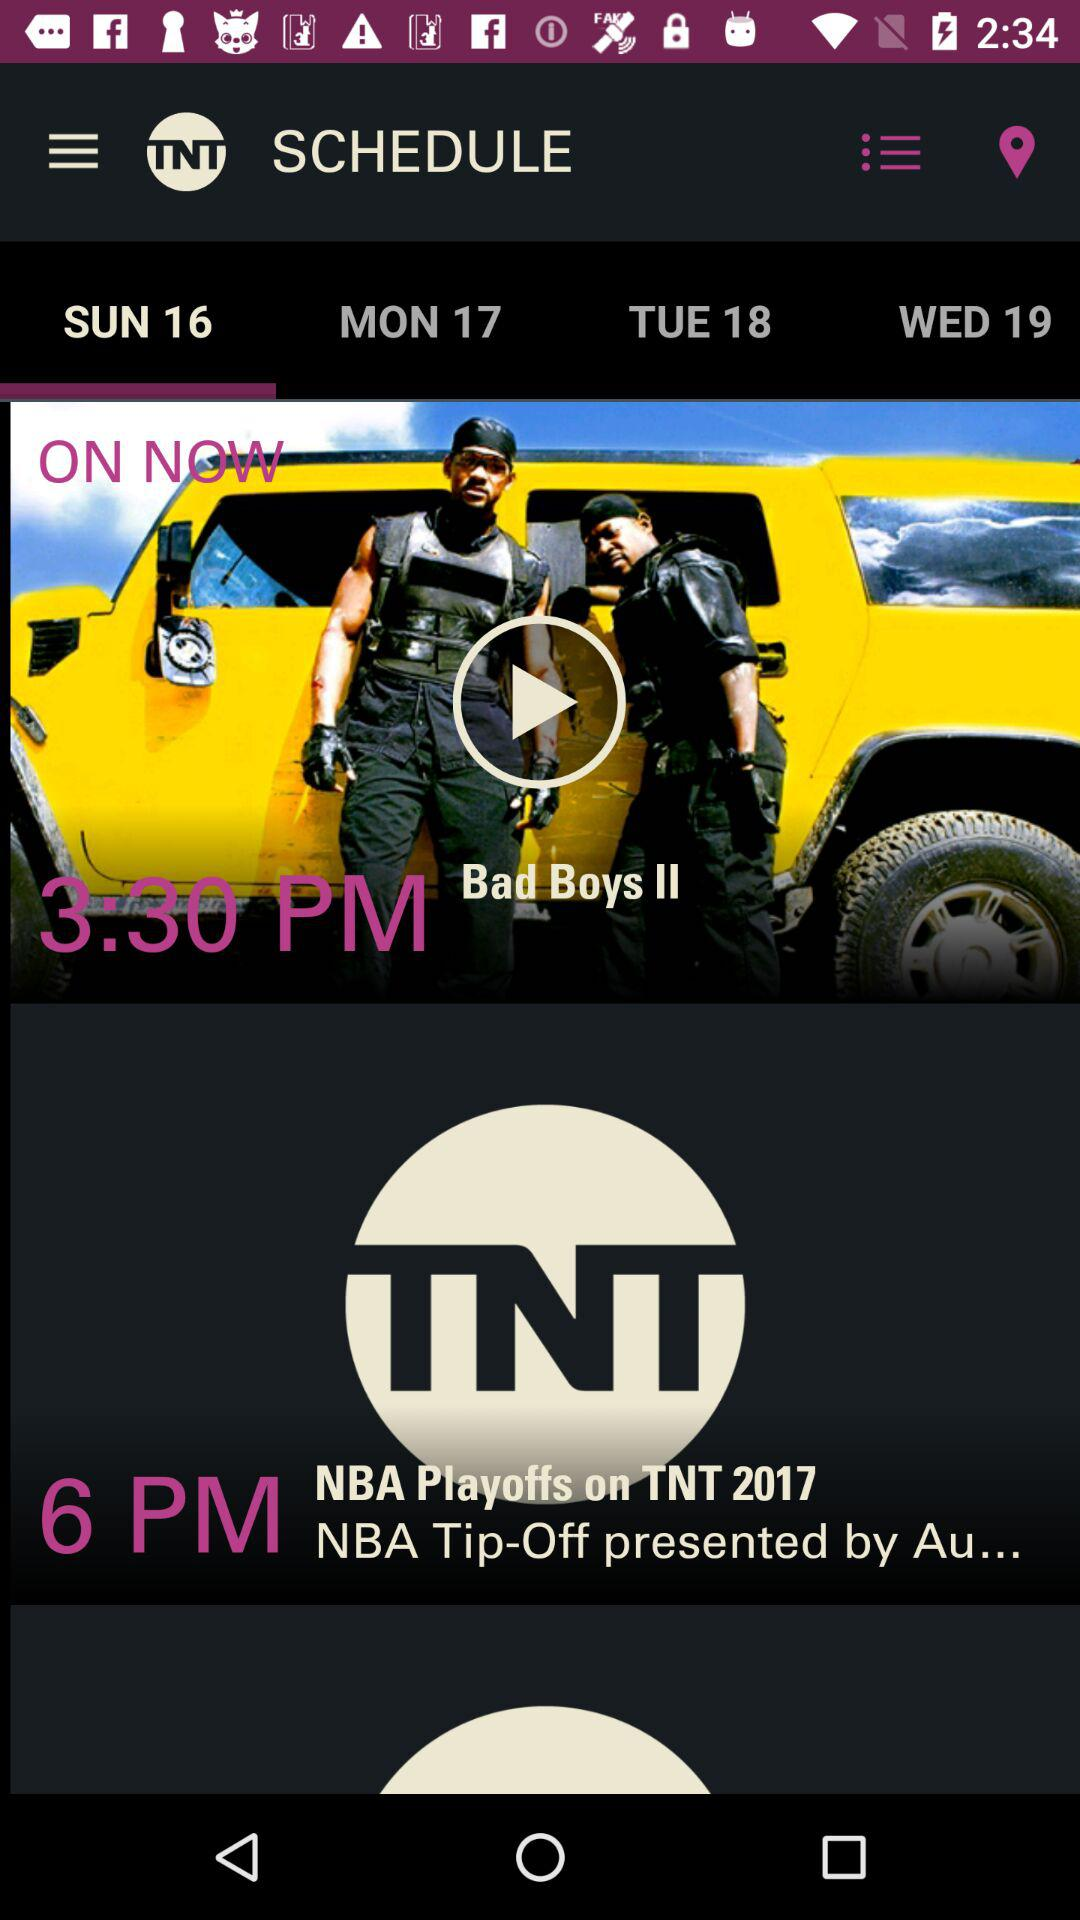What is the scheduled time of "Bad Boys II"? The scheduled time is 3:30 PM. 